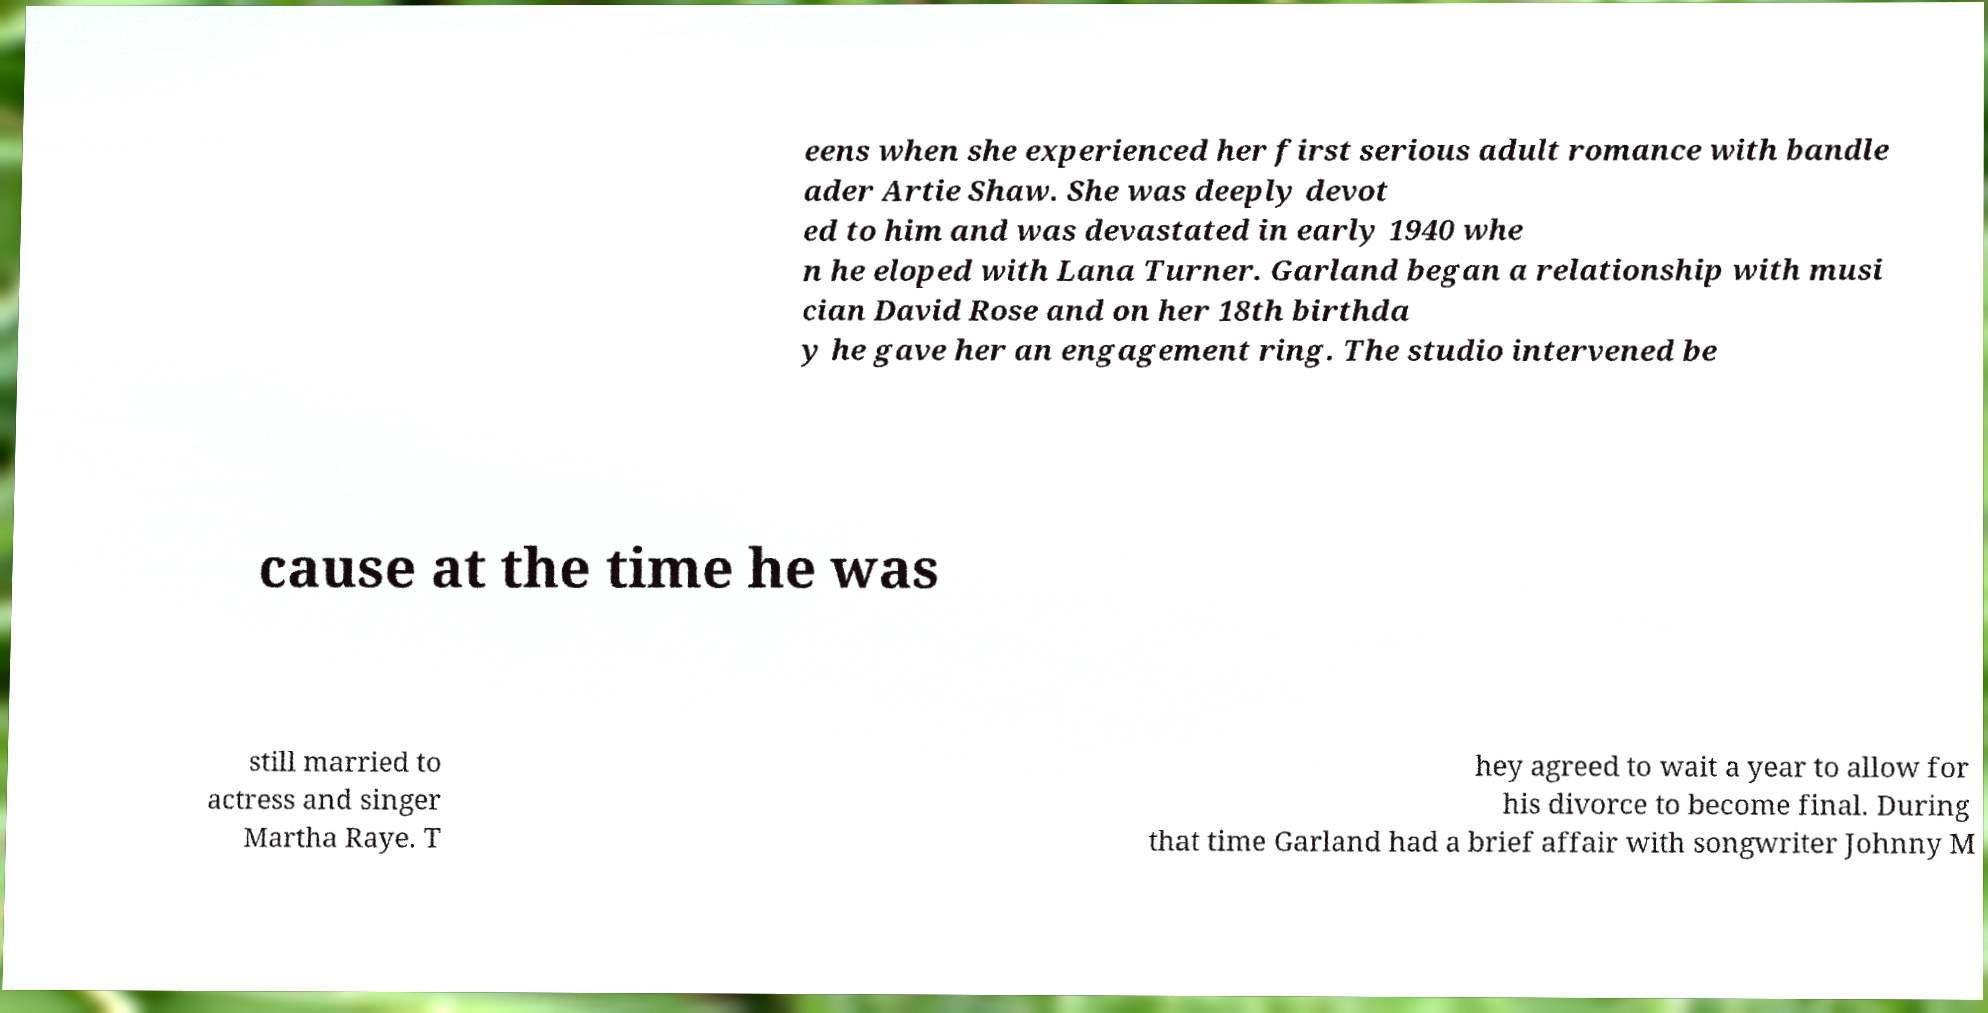Could you assist in decoding the text presented in this image and type it out clearly? eens when she experienced her first serious adult romance with bandle ader Artie Shaw. She was deeply devot ed to him and was devastated in early 1940 whe n he eloped with Lana Turner. Garland began a relationship with musi cian David Rose and on her 18th birthda y he gave her an engagement ring. The studio intervened be cause at the time he was still married to actress and singer Martha Raye. T hey agreed to wait a year to allow for his divorce to become final. During that time Garland had a brief affair with songwriter Johnny M 